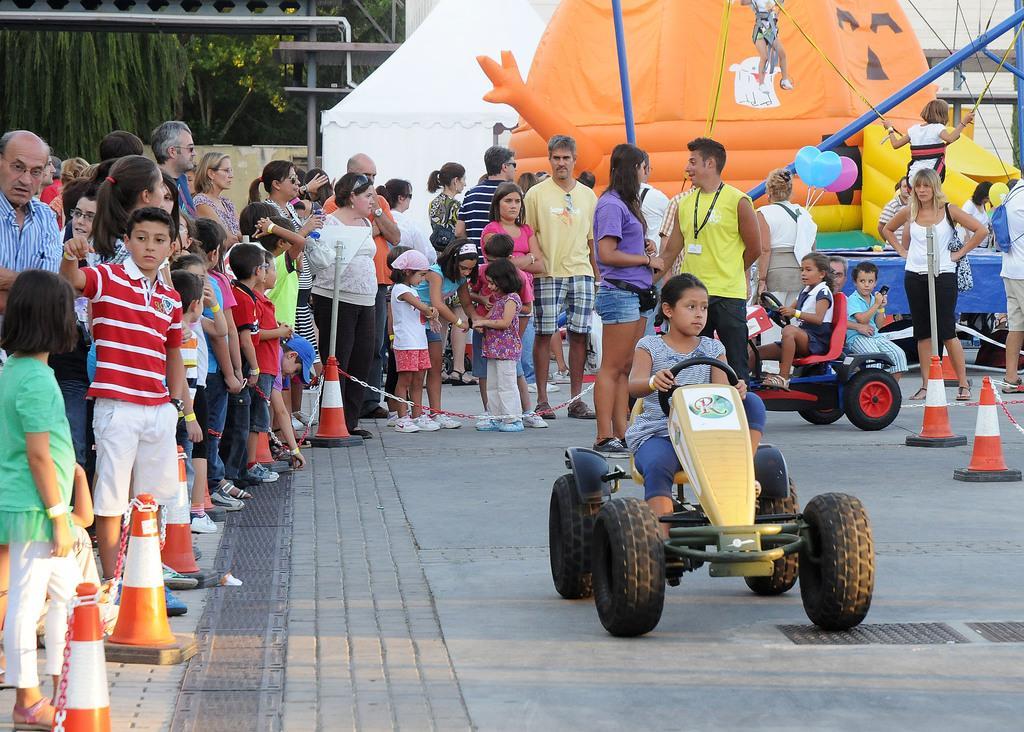In one or two sentences, can you explain what this image depicts? This image consists of many people standing. At the bottom, there is a road. In the middle, there is a vehicle on which a girl is sitting. In the background, there are trees and tents. 